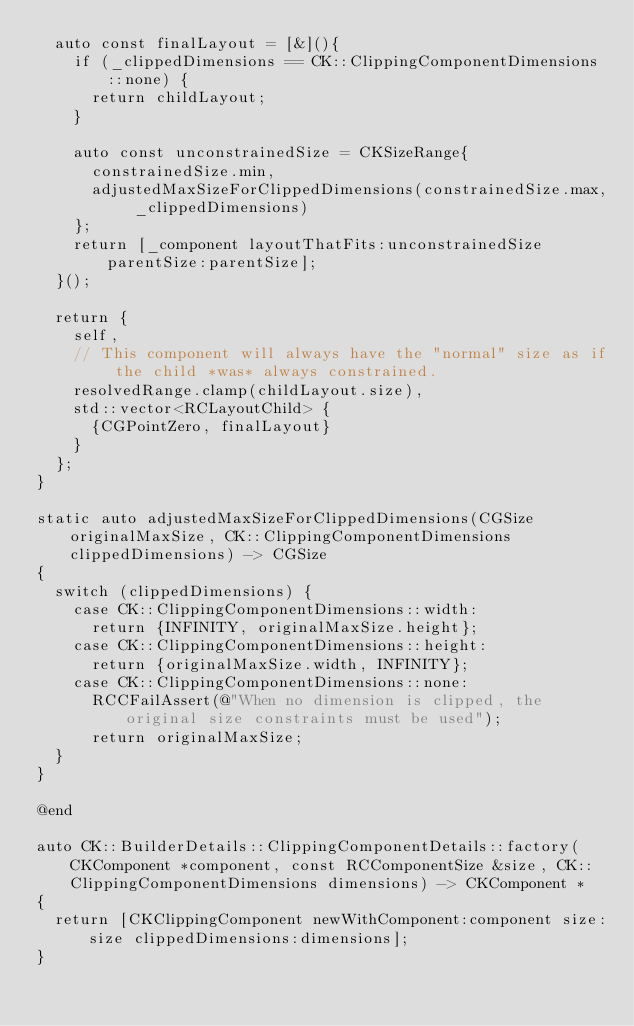<code> <loc_0><loc_0><loc_500><loc_500><_ObjectiveC_>  auto const finalLayout = [&](){
    if (_clippedDimensions == CK::ClippingComponentDimensions::none) {
      return childLayout;
    }

    auto const unconstrainedSize = CKSizeRange{
      constrainedSize.min,
      adjustedMaxSizeForClippedDimensions(constrainedSize.max, _clippedDimensions)
    };
    return [_component layoutThatFits:unconstrainedSize parentSize:parentSize];
  }();

  return {
    self,
    // This component will always have the "normal" size as if the child *was* always constrained.
    resolvedRange.clamp(childLayout.size),
    std::vector<RCLayoutChild> {
      {CGPointZero, finalLayout}
    }
  };
}

static auto adjustedMaxSizeForClippedDimensions(CGSize originalMaxSize, CK::ClippingComponentDimensions clippedDimensions) -> CGSize
{
  switch (clippedDimensions) {
    case CK::ClippingComponentDimensions::width:
      return {INFINITY, originalMaxSize.height};
    case CK::ClippingComponentDimensions::height:
      return {originalMaxSize.width, INFINITY};
    case CK::ClippingComponentDimensions::none:
      RCCFailAssert(@"When no dimension is clipped, the original size constraints must be used");
      return originalMaxSize;
  }
}

@end

auto CK::BuilderDetails::ClippingComponentDetails::factory(CKComponent *component, const RCComponentSize &size, CK::ClippingComponentDimensions dimensions) -> CKComponent *
{
  return [CKClippingComponent newWithComponent:component size:size clippedDimensions:dimensions];
}
</code> 